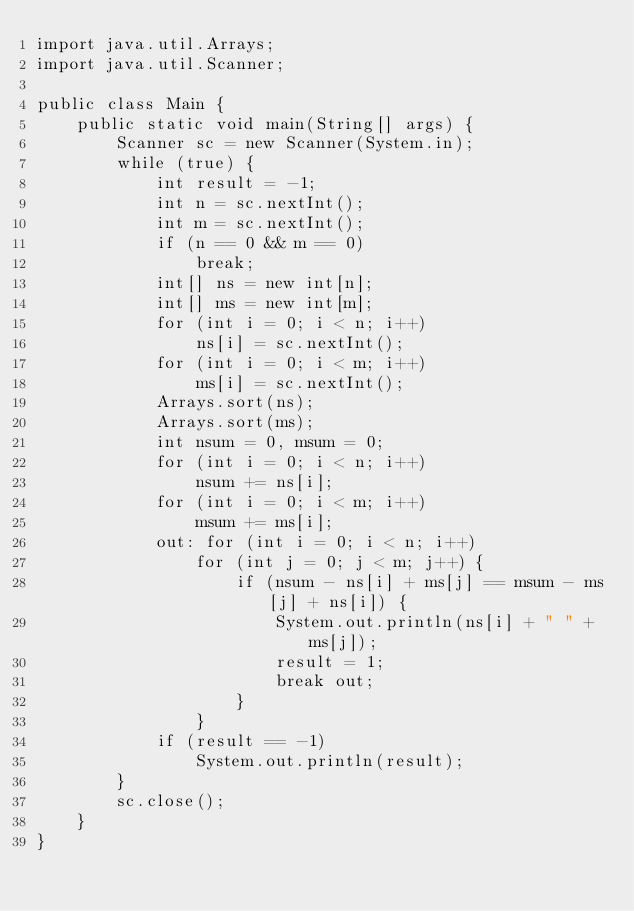Convert code to text. <code><loc_0><loc_0><loc_500><loc_500><_Java_>import java.util.Arrays;
import java.util.Scanner;

public class Main {
	public static void main(String[] args) {
		Scanner sc = new Scanner(System.in);
		while (true) {
			int result = -1;
			int n = sc.nextInt();
			int m = sc.nextInt();
			if (n == 0 && m == 0)
				break;
			int[] ns = new int[n];
			int[] ms = new int[m];
			for (int i = 0; i < n; i++)
				ns[i] = sc.nextInt();
			for (int i = 0; i < m; i++)
				ms[i] = sc.nextInt();
			Arrays.sort(ns);
			Arrays.sort(ms);
			int nsum = 0, msum = 0;
			for (int i = 0; i < n; i++)
				nsum += ns[i];
			for (int i = 0; i < m; i++)
				msum += ms[i];
			out: for (int i = 0; i < n; i++)
				for (int j = 0; j < m; j++) {
					if (nsum - ns[i] + ms[j] == msum - ms[j] + ns[i]) {
						System.out.println(ns[i] + " " + ms[j]);
						result = 1;
						break out;
					}
				}
			if (result == -1)
				System.out.println(result);
		}
		sc.close();
	}
}</code> 